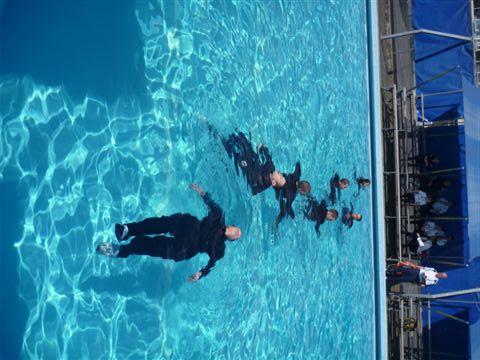Are they swimming in open water?
Answer briefly. No. Are there spectators?
Give a very brief answer. Yes. What are these people doing in the water?
Quick response, please. Swimming. 